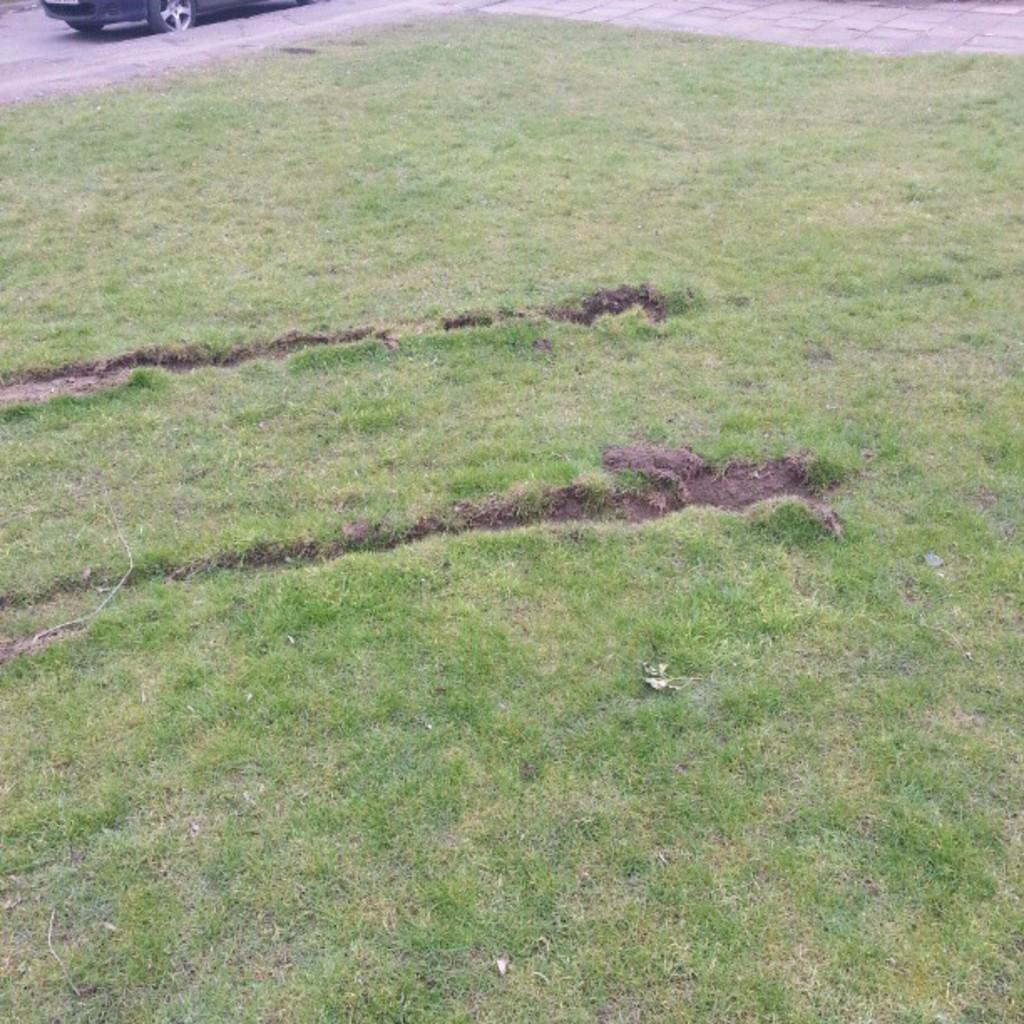What is the main subject of the image? There is a vehicle on the road in the image. What can be seen in the foreground of the image? There is grass in the foreground of the image. What type of kettle is visible in the image? There is no kettle present in the image. What is the weather like in the image? The provided facts do not mention the weather, so we cannot determine the weather from the image. 